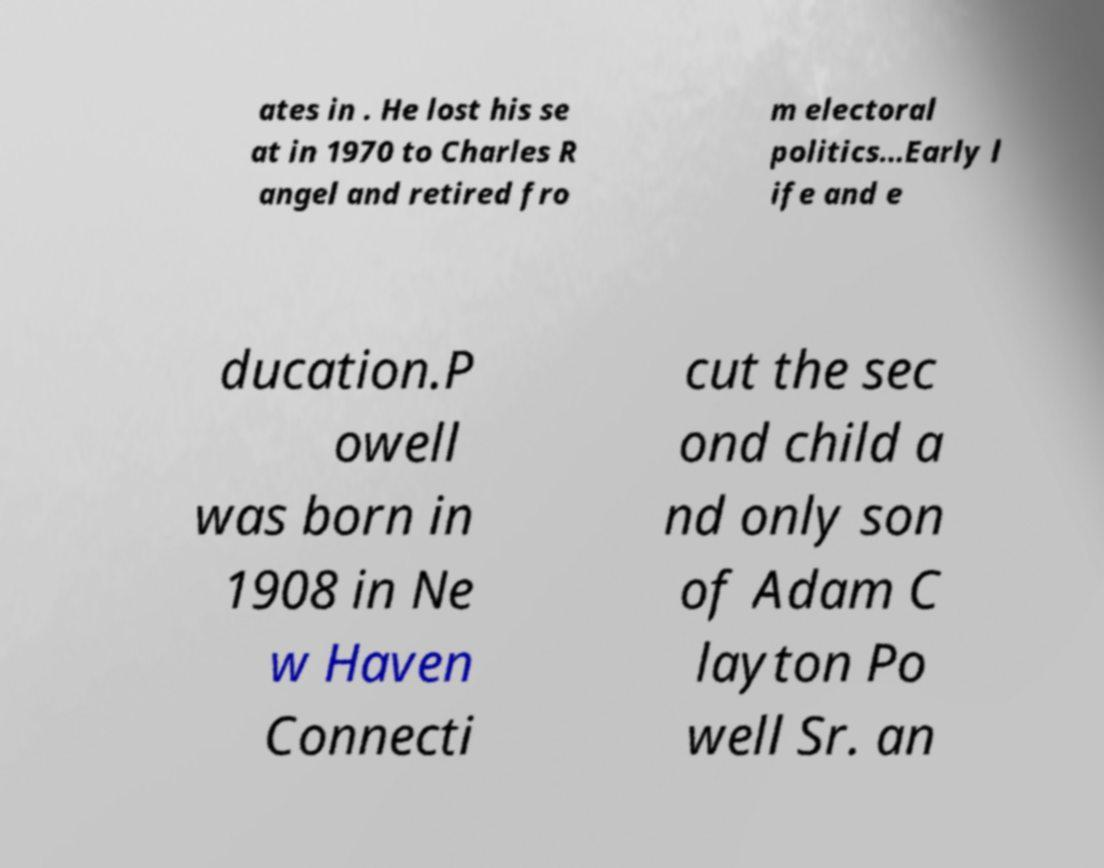Please identify and transcribe the text found in this image. ates in . He lost his se at in 1970 to Charles R angel and retired fro m electoral politics…Early l ife and e ducation.P owell was born in 1908 in Ne w Haven Connecti cut the sec ond child a nd only son of Adam C layton Po well Sr. an 